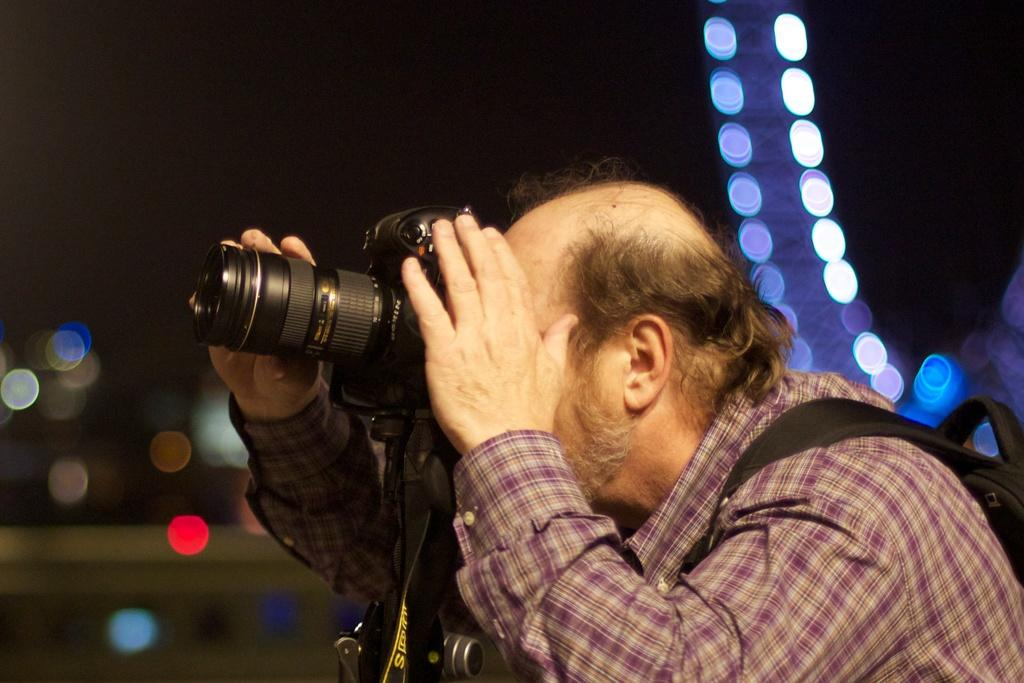What is the main subject of the image? There is a man in the image. What is the man wearing? The man is wearing a shirt. What is the man holding in addition to the camera? The man is holding a bag. What is the man doing in the image? The man is standing and holding a camera. What can be seen in the background of the image? The sky is dark, and there are lights visible in the background of the image. How many rabbits are sitting on the home in the image? There are no rabbits or homes present in the image. What type of cork is used to seal the bag the man is holding? There is no information about the type of cork used to seal the bag, and the bag is not the main focus of the image. 